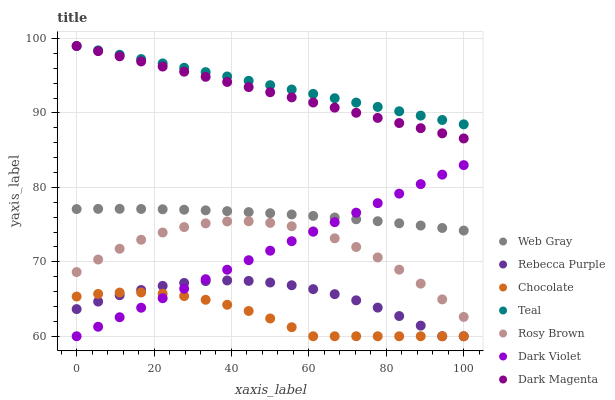Does Chocolate have the minimum area under the curve?
Answer yes or no. Yes. Does Teal have the maximum area under the curve?
Answer yes or no. Yes. Does Dark Magenta have the minimum area under the curve?
Answer yes or no. No. Does Dark Magenta have the maximum area under the curve?
Answer yes or no. No. Is Dark Violet the smoothest?
Answer yes or no. Yes. Is Rosy Brown the roughest?
Answer yes or no. Yes. Is Dark Magenta the smoothest?
Answer yes or no. No. Is Dark Magenta the roughest?
Answer yes or no. No. Does Dark Violet have the lowest value?
Answer yes or no. Yes. Does Dark Magenta have the lowest value?
Answer yes or no. No. Does Teal have the highest value?
Answer yes or no. Yes. Does Rosy Brown have the highest value?
Answer yes or no. No. Is Rosy Brown less than Dark Magenta?
Answer yes or no. Yes. Is Dark Magenta greater than Web Gray?
Answer yes or no. Yes. Does Chocolate intersect Dark Violet?
Answer yes or no. Yes. Is Chocolate less than Dark Violet?
Answer yes or no. No. Is Chocolate greater than Dark Violet?
Answer yes or no. No. Does Rosy Brown intersect Dark Magenta?
Answer yes or no. No. 